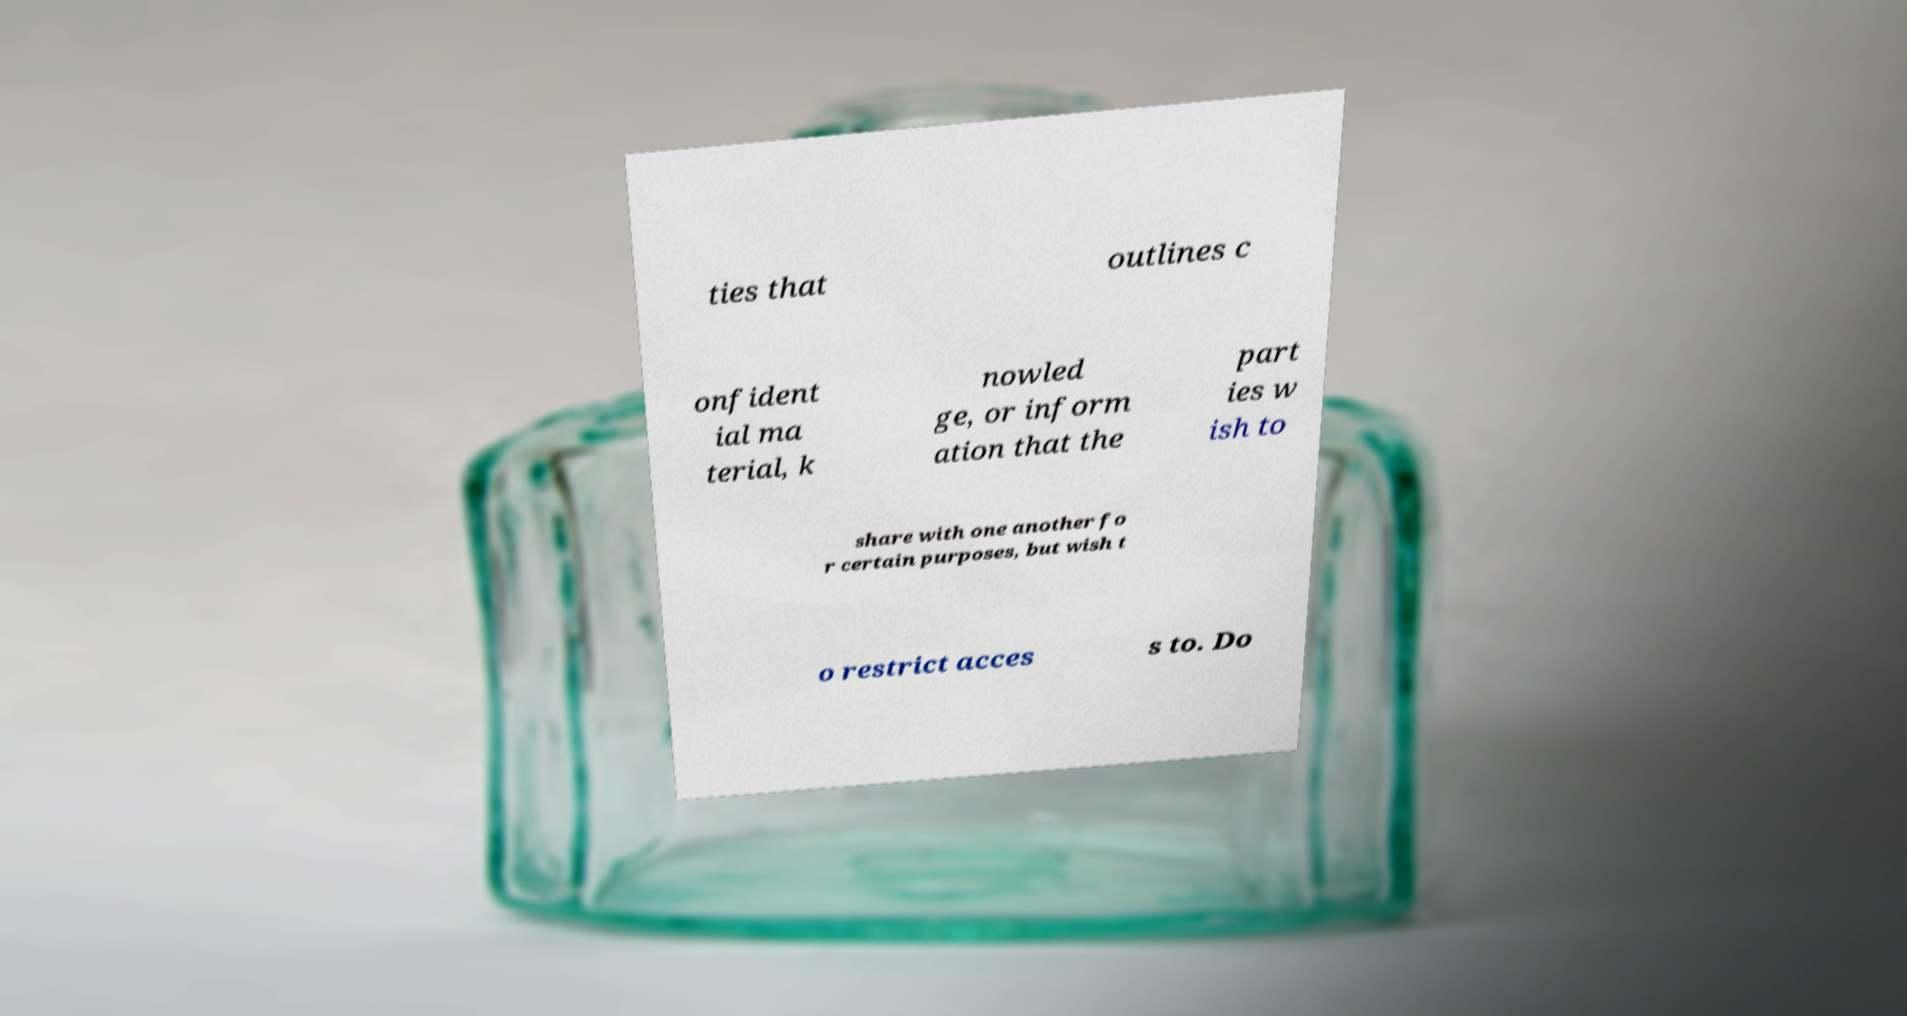There's text embedded in this image that I need extracted. Can you transcribe it verbatim? ties that outlines c onfident ial ma terial, k nowled ge, or inform ation that the part ies w ish to share with one another fo r certain purposes, but wish t o restrict acces s to. Do 